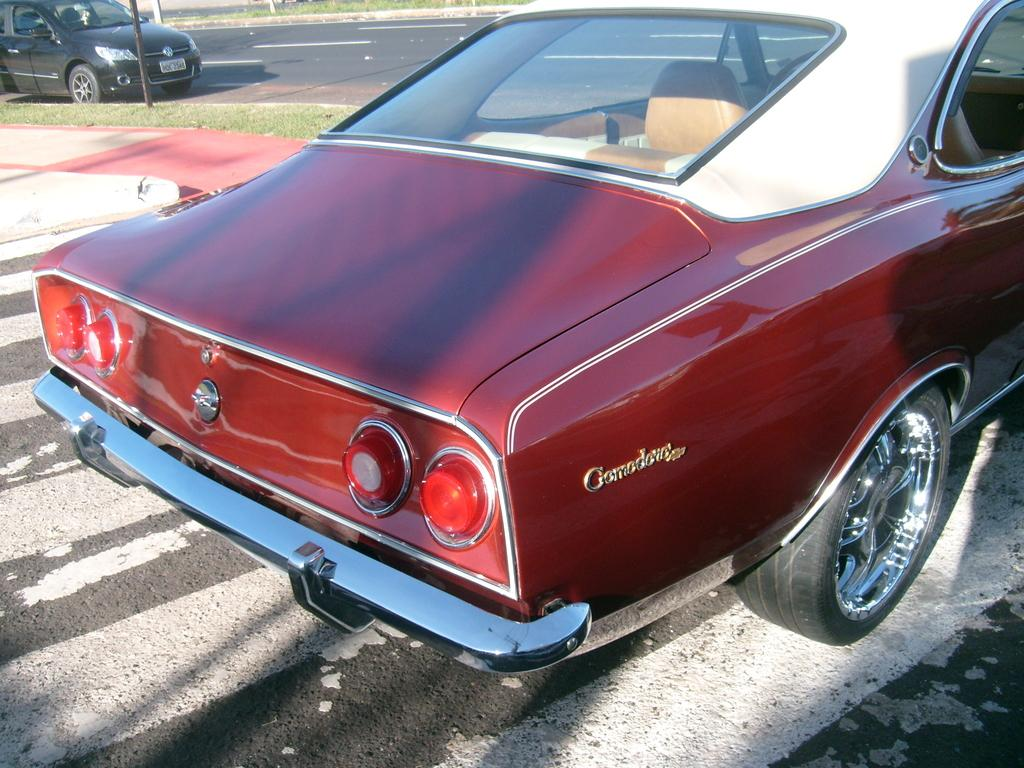What is the main subject of the image? There is a car in the image. Can you describe the color of the car? The car is brown. What is visible at the bottom of the image? There is a road at the bottom of the image. Are there any other cars in the image? Yes, there is another car in the background of the image. What is the color of the background car? The background car is black. What type of vegetation is present in the image? There is grass on the ground in the image. Can you tell me how many toes the frog has in the image? There is no frog present in the image, so it is not possible to determine the number of toes it might have. 